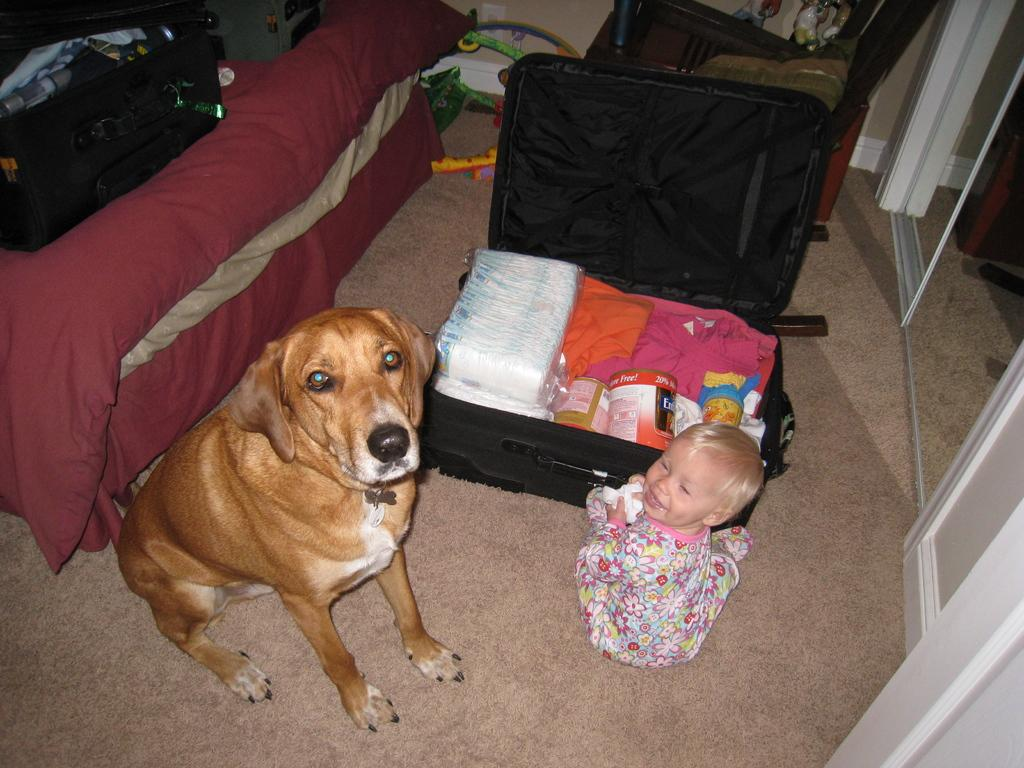What is the baby doing in the image? The baby is sitting on the floor in the image. What other living creature is present in the image? There is a dog in the image. What object can be seen in the image that might be used for traveling? There is a suitcase in the image. What items are inside the suitcase? The suitcase contains clothes, an iron box, and napkins. What route does the baby take to get to the property in the image? There is no mention of a route or property in the image; the focus is on the baby, the dog, and the suitcase. 